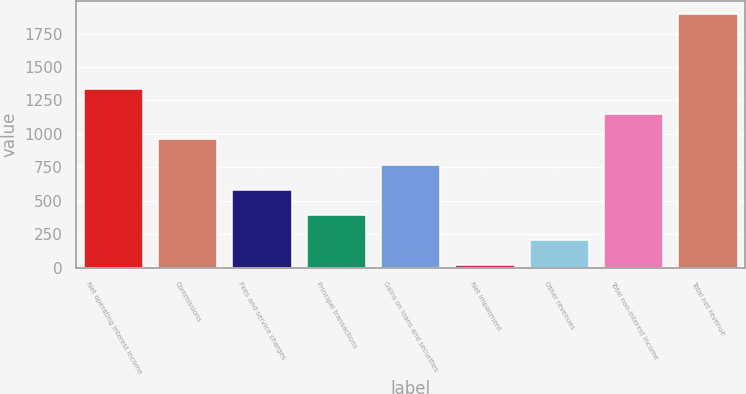Convert chart to OTSL. <chart><loc_0><loc_0><loc_500><loc_500><bar_chart><fcel>Net operating interest income<fcel>Commissions<fcel>Fees and service charges<fcel>Principal transactions<fcel>Gains on loans and securities<fcel>Net impairment<fcel>Other revenues<fcel>Total non-interest income<fcel>Total net revenue<nl><fcel>1334.72<fcel>958.2<fcel>581.68<fcel>393.42<fcel>769.94<fcel>16.9<fcel>205.16<fcel>1146.46<fcel>1899.5<nl></chart> 